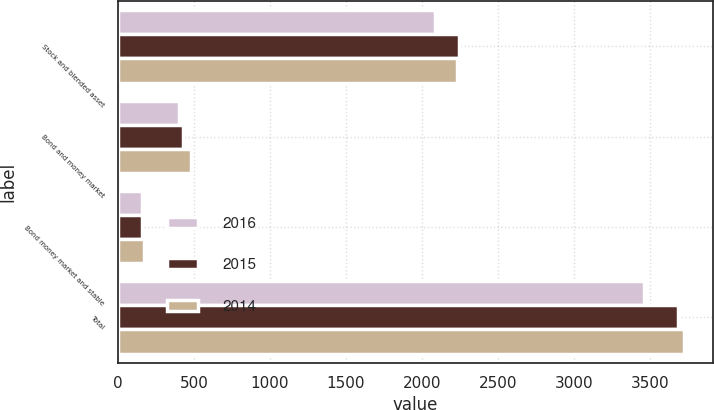Convert chart to OTSL. <chart><loc_0><loc_0><loc_500><loc_500><stacked_bar_chart><ecel><fcel>Stock and blended asset<fcel>Bond and money market<fcel>Bond money market and stable<fcel>Total<nl><fcel>2016<fcel>2086<fcel>399.8<fcel>154.2<fcel>3464.5<nl><fcel>2015<fcel>2241.9<fcel>426<fcel>157.2<fcel>3687.3<nl><fcel>2014<fcel>2228.1<fcel>477.3<fcel>173<fcel>3728.7<nl></chart> 